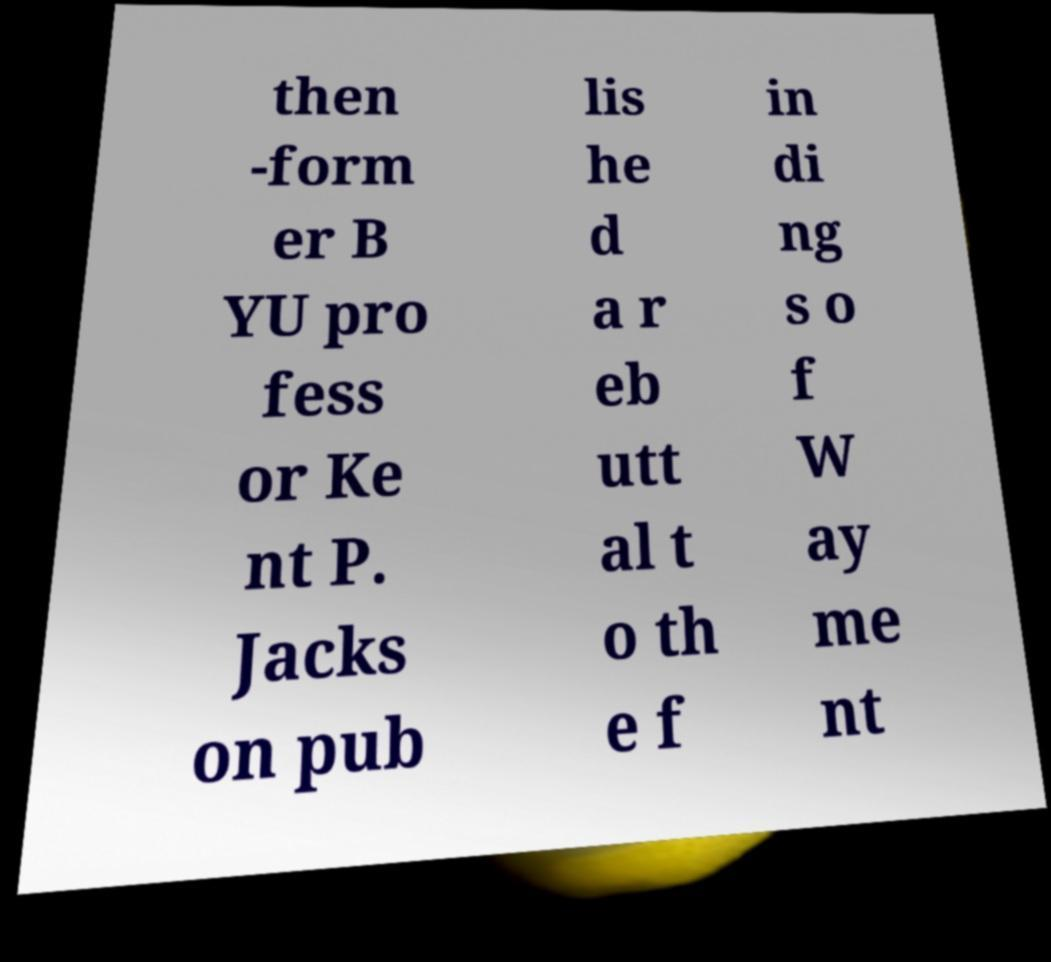There's text embedded in this image that I need extracted. Can you transcribe it verbatim? then -form er B YU pro fess or Ke nt P. Jacks on pub lis he d a r eb utt al t o th e f in di ng s o f W ay me nt 